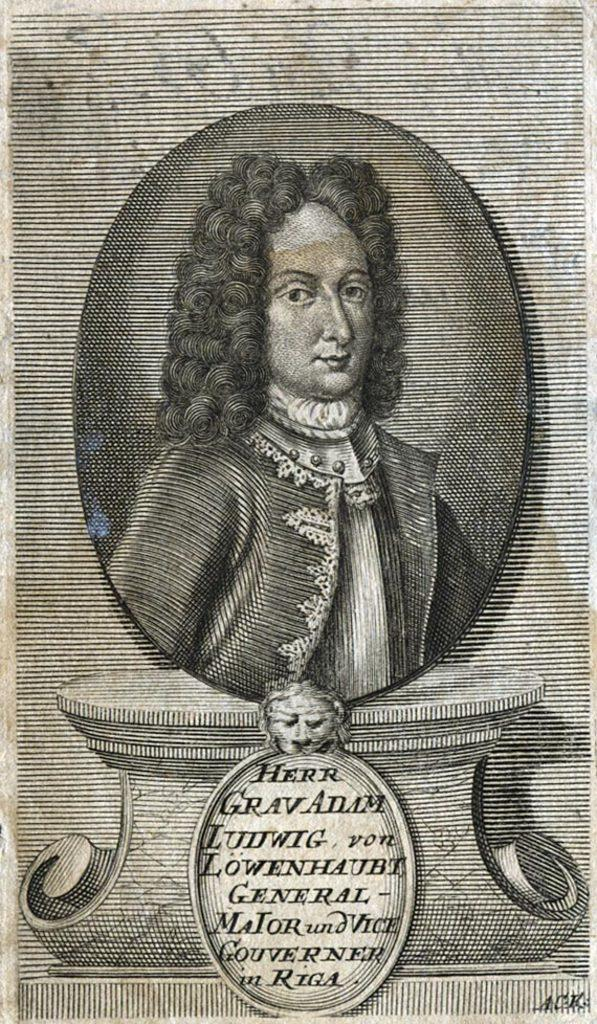What is the main subject of the image? The main subject of the image is a person's photograph. Is there any text associated with the photograph? Yes, there is text at the bottom of the image. What is the text written on? The text appears to be on a paper. What title does the person in the photograph hold? There is no information about the person's title in the image. Is the person in the photograph reading a book in the image? There is no book or any indication of reading in the image. 